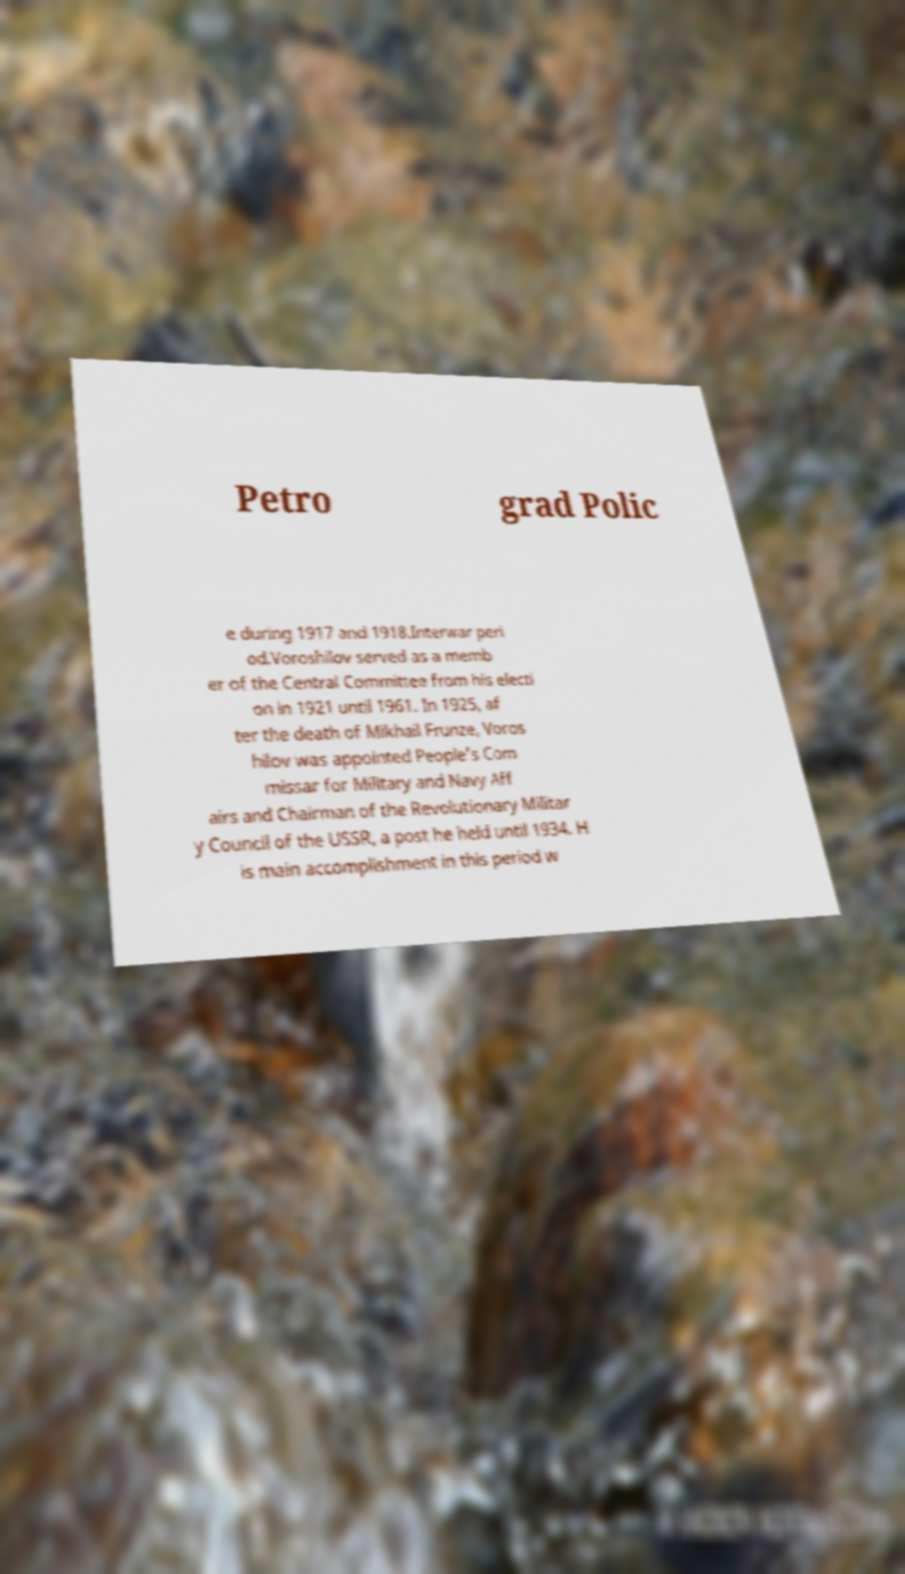There's text embedded in this image that I need extracted. Can you transcribe it verbatim? Petro grad Polic e during 1917 and 1918.Interwar peri od.Voroshilov served as a memb er of the Central Committee from his electi on in 1921 until 1961. In 1925, af ter the death of Mikhail Frunze, Voros hilov was appointed People's Com missar for Military and Navy Aff airs and Chairman of the Revolutionary Militar y Council of the USSR, a post he held until 1934. H is main accomplishment in this period w 